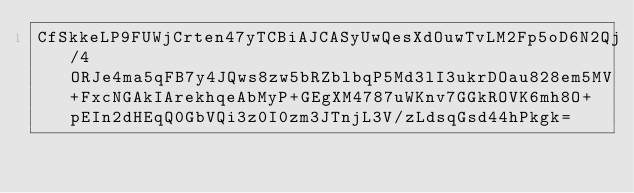Convert code to text. <code><loc_0><loc_0><loc_500><loc_500><_SML_>CfSkkeLP9FUWjCrten47yTCBiAJCASyUwQesXdOuwTvLM2Fp5oD6N2Qj/4ORJe4ma5qFB7y4JQws8zw5bRZblbqP5Md3lI3ukrDOau828em5MV+FxcNGAkIArekhqeAbMyP+GEgXM4787uWKnv7GGkROVK6mh8O+pEIn2dHEqQ0GbVQi3z0I0zm3JTnjL3V/zLdsqGsd44hPkgk=</code> 